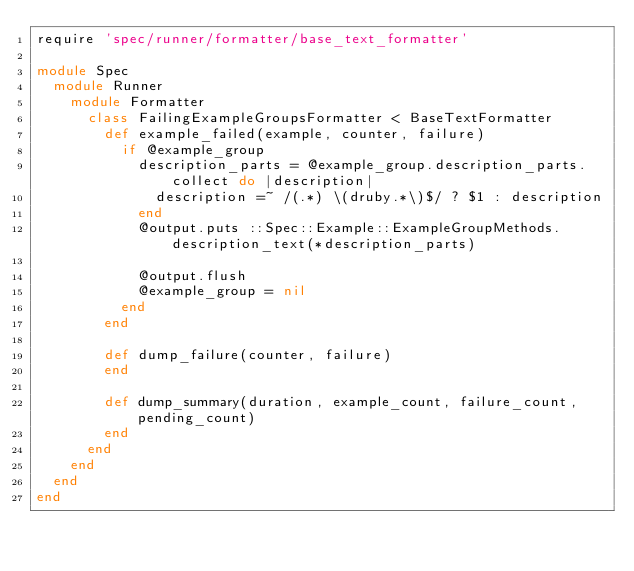Convert code to text. <code><loc_0><loc_0><loc_500><loc_500><_Ruby_>require 'spec/runner/formatter/base_text_formatter'

module Spec
  module Runner
    module Formatter
      class FailingExampleGroupsFormatter < BaseTextFormatter
        def example_failed(example, counter, failure)
          if @example_group
            description_parts = @example_group.description_parts.collect do |description|
              description =~ /(.*) \(druby.*\)$/ ? $1 : description
            end
            @output.puts ::Spec::Example::ExampleGroupMethods.description_text(*description_parts)

            @output.flush
            @example_group = nil
          end
        end

        def dump_failure(counter, failure)
        end

        def dump_summary(duration, example_count, failure_count, pending_count)
        end
      end
    end
  end
end
</code> 